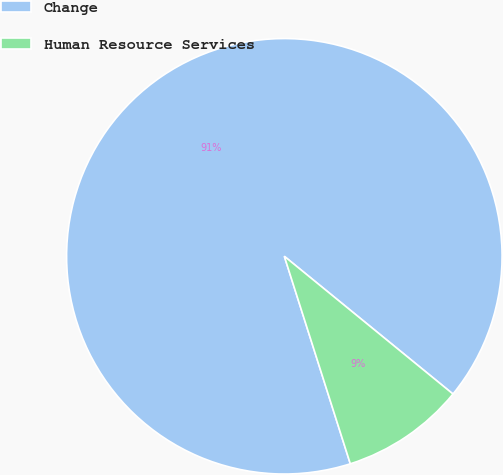Convert chart. <chart><loc_0><loc_0><loc_500><loc_500><pie_chart><fcel>Change<fcel>Human Resource Services<nl><fcel>90.8%<fcel>9.2%<nl></chart> 